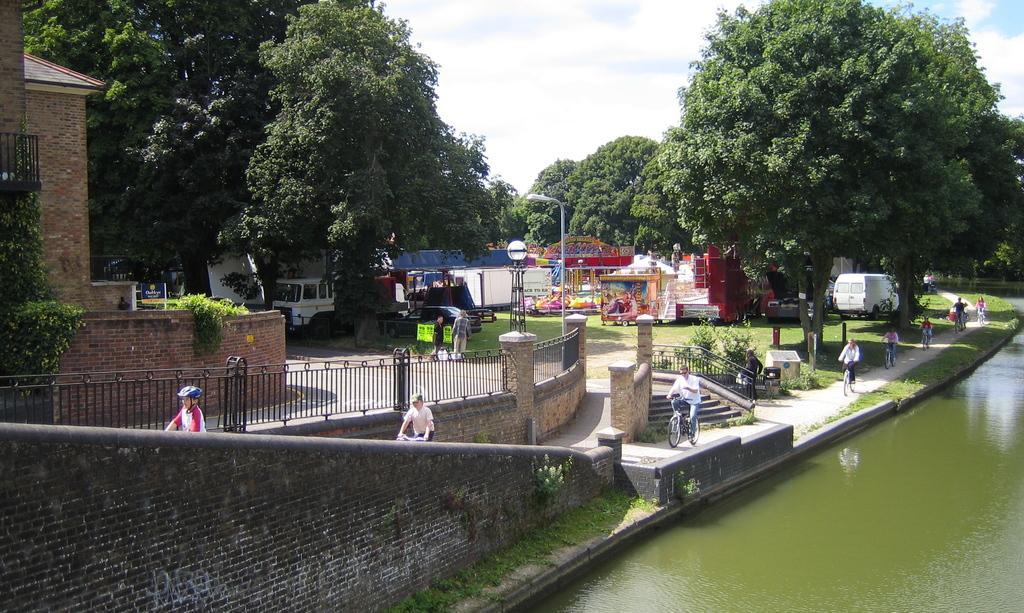Describe this image in one or two sentences. In this picture there are people riding bicycles on the path and we can see water, grass, plants, wall and fences. There are two people standing and we can see trees, board, poles, light, vehicles, trees and objects. In the background of the image we can see the sky with clouds. 